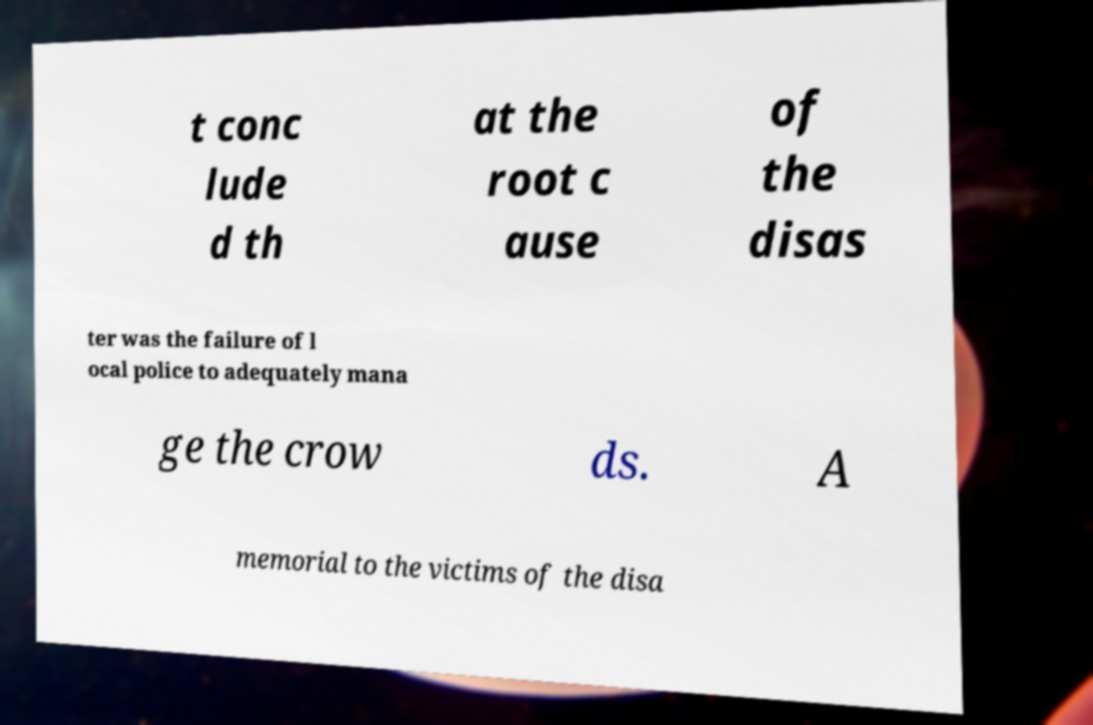Can you accurately transcribe the text from the provided image for me? t conc lude d th at the root c ause of the disas ter was the failure of l ocal police to adequately mana ge the crow ds. A memorial to the victims of the disa 